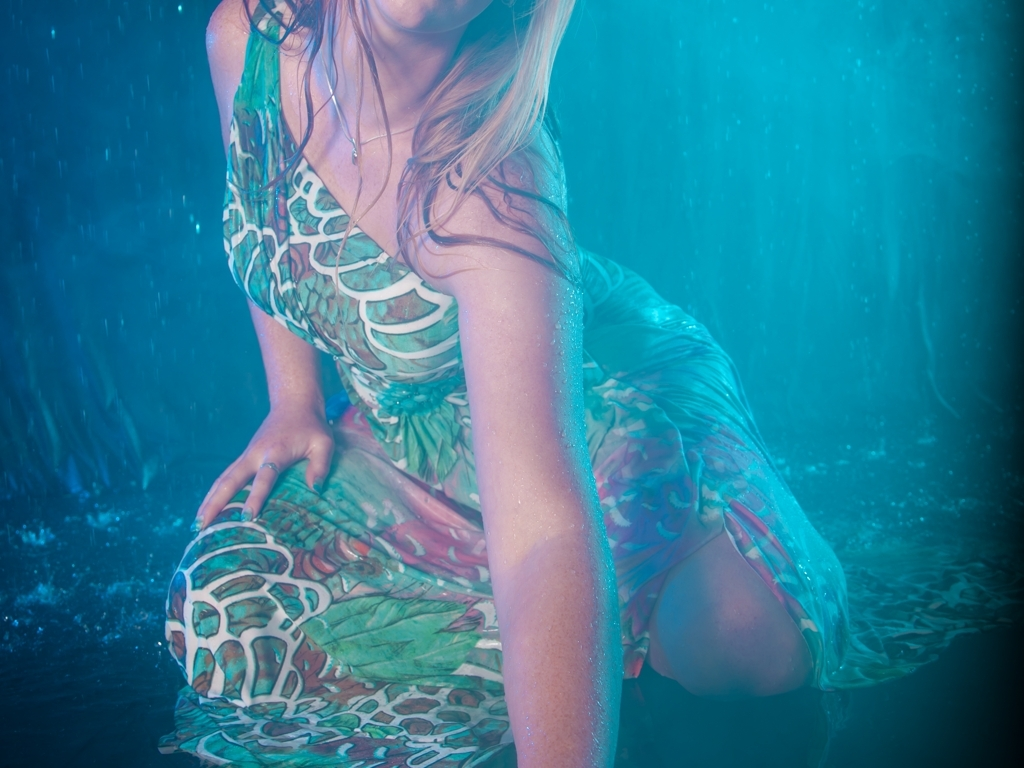What can you infer about the setting or location from the elements in the photo? The blue-tinted background, along with the presence of water droplets, suggests that the setting could be underwater or designed to create the illusion of being underwater. It is likely a controlled environment, such as a photography studio, where such effects can be created artificially to set the artistically wet and immersive atmosphere. 